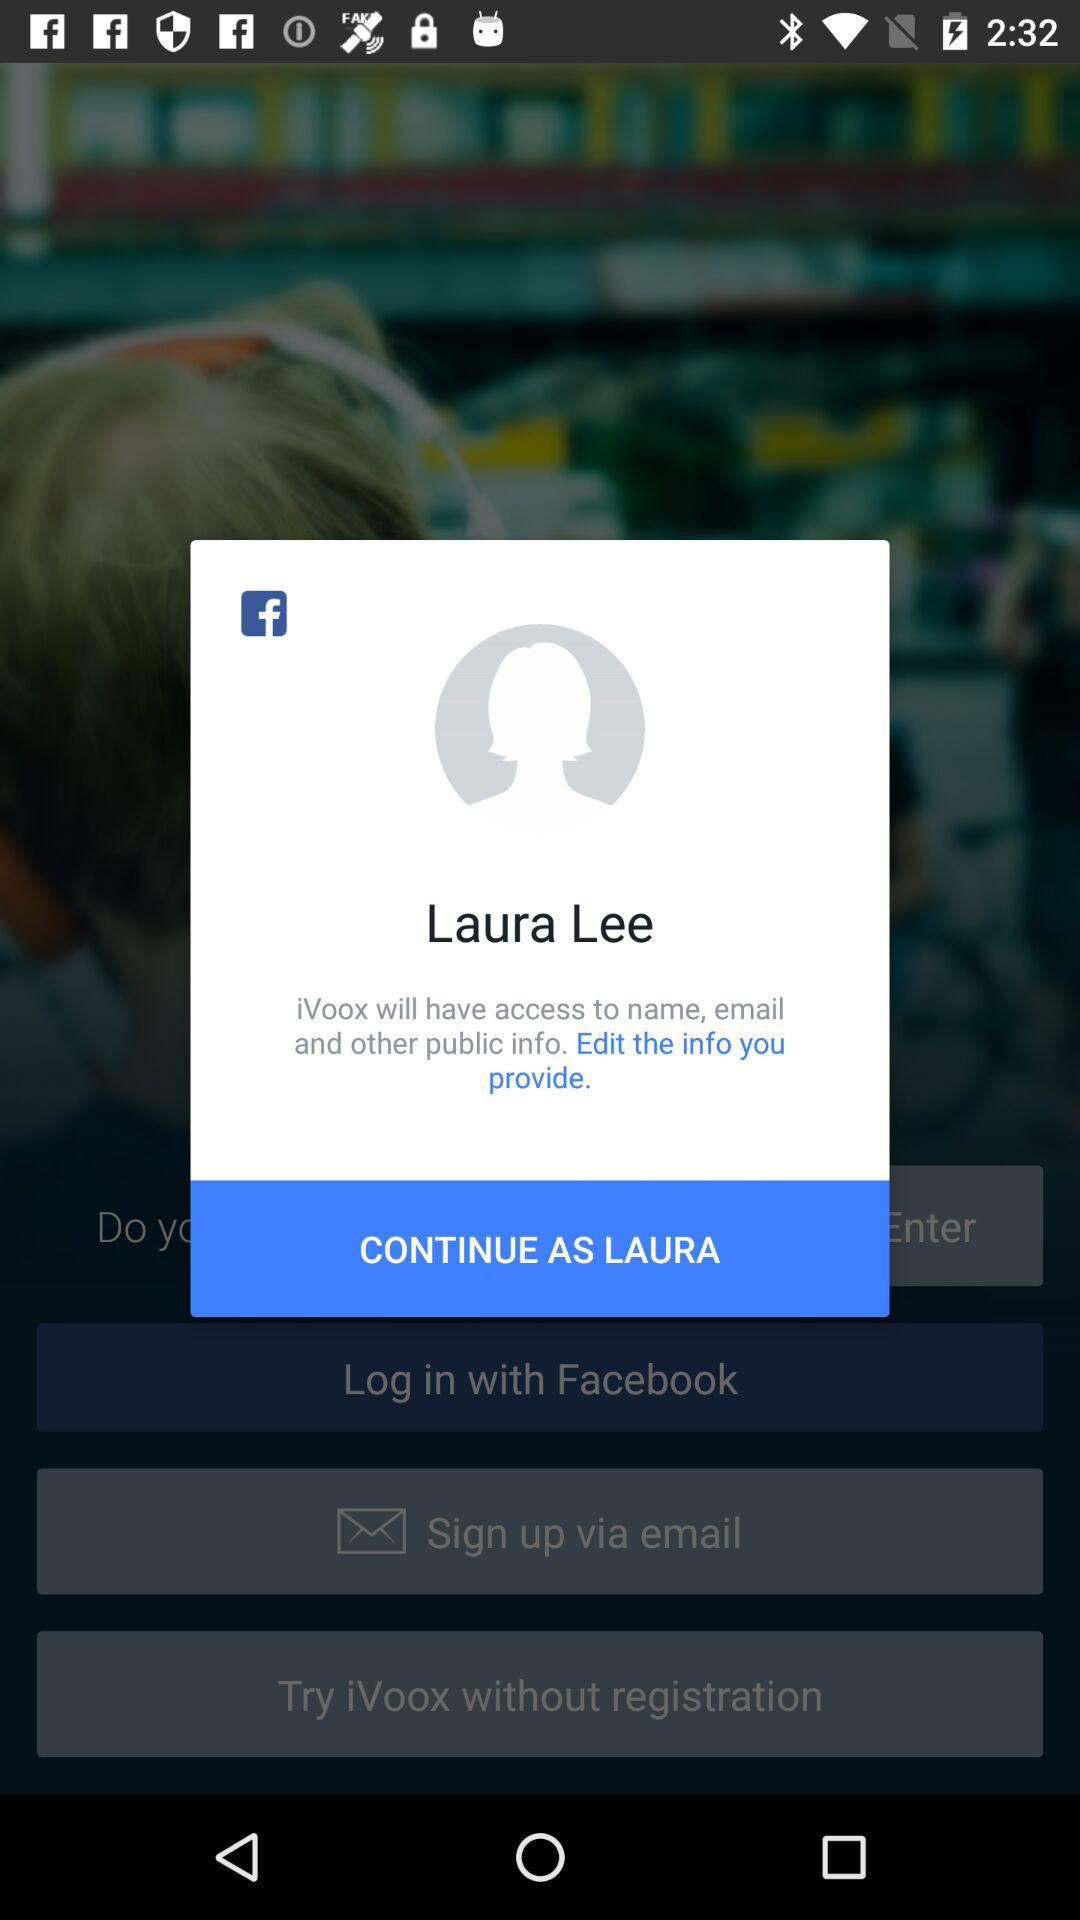What application will have access to the name and email? The application is "iVoox". 